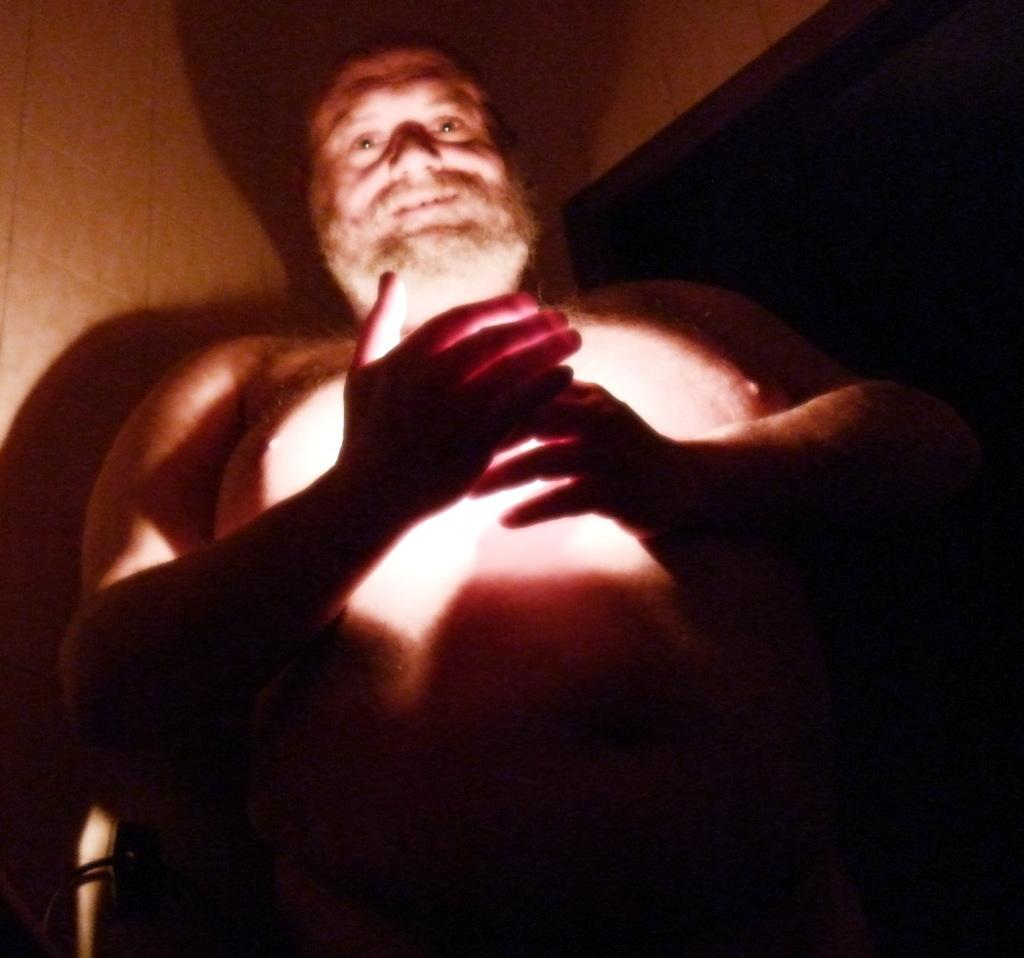What is the main subject of the image? The main subject of the image is a man standing. Can you describe the background of the image? There is a wall visible in the background of the image. What type of hand can be seen shocking the man in the image? There is no hand or any indication of shocking present in the image. Can you tell me how many geese are visible in the image? There are no geese present in the image. 